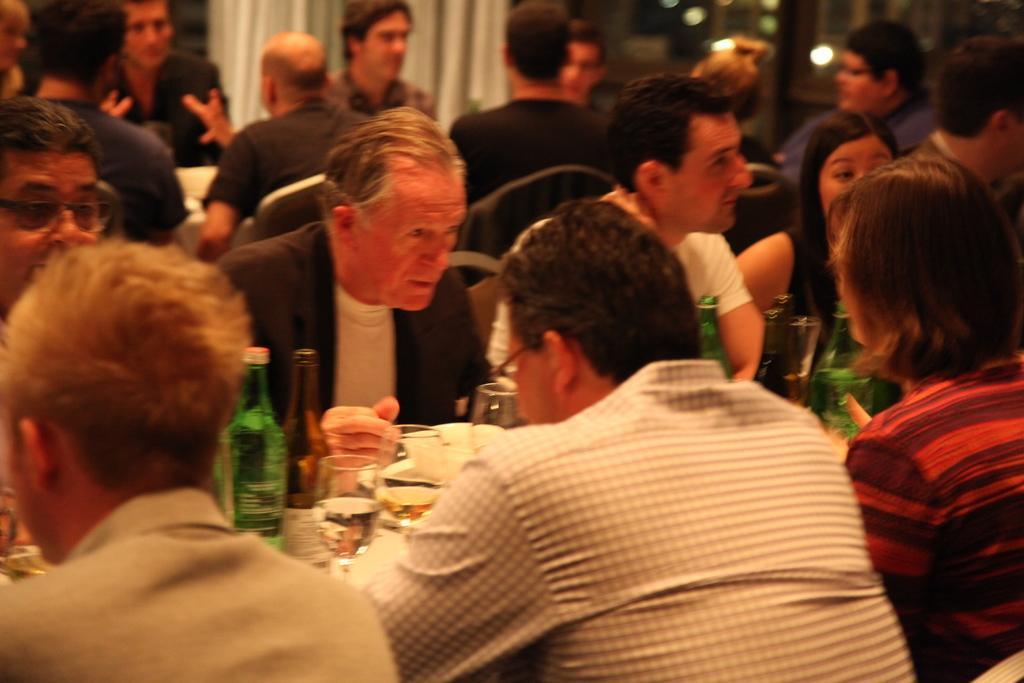In one or two sentences, can you explain what this image depicts? In the middle of the image few people are sitting and there are some tables, on the tables there are some bottles and glasses and plates and food. 